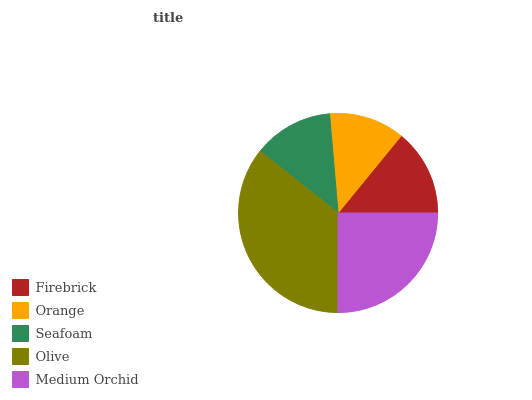Is Orange the minimum?
Answer yes or no. Yes. Is Olive the maximum?
Answer yes or no. Yes. Is Seafoam the minimum?
Answer yes or no. No. Is Seafoam the maximum?
Answer yes or no. No. Is Seafoam greater than Orange?
Answer yes or no. Yes. Is Orange less than Seafoam?
Answer yes or no. Yes. Is Orange greater than Seafoam?
Answer yes or no. No. Is Seafoam less than Orange?
Answer yes or no. No. Is Firebrick the high median?
Answer yes or no. Yes. Is Firebrick the low median?
Answer yes or no. Yes. Is Seafoam the high median?
Answer yes or no. No. Is Orange the low median?
Answer yes or no. No. 